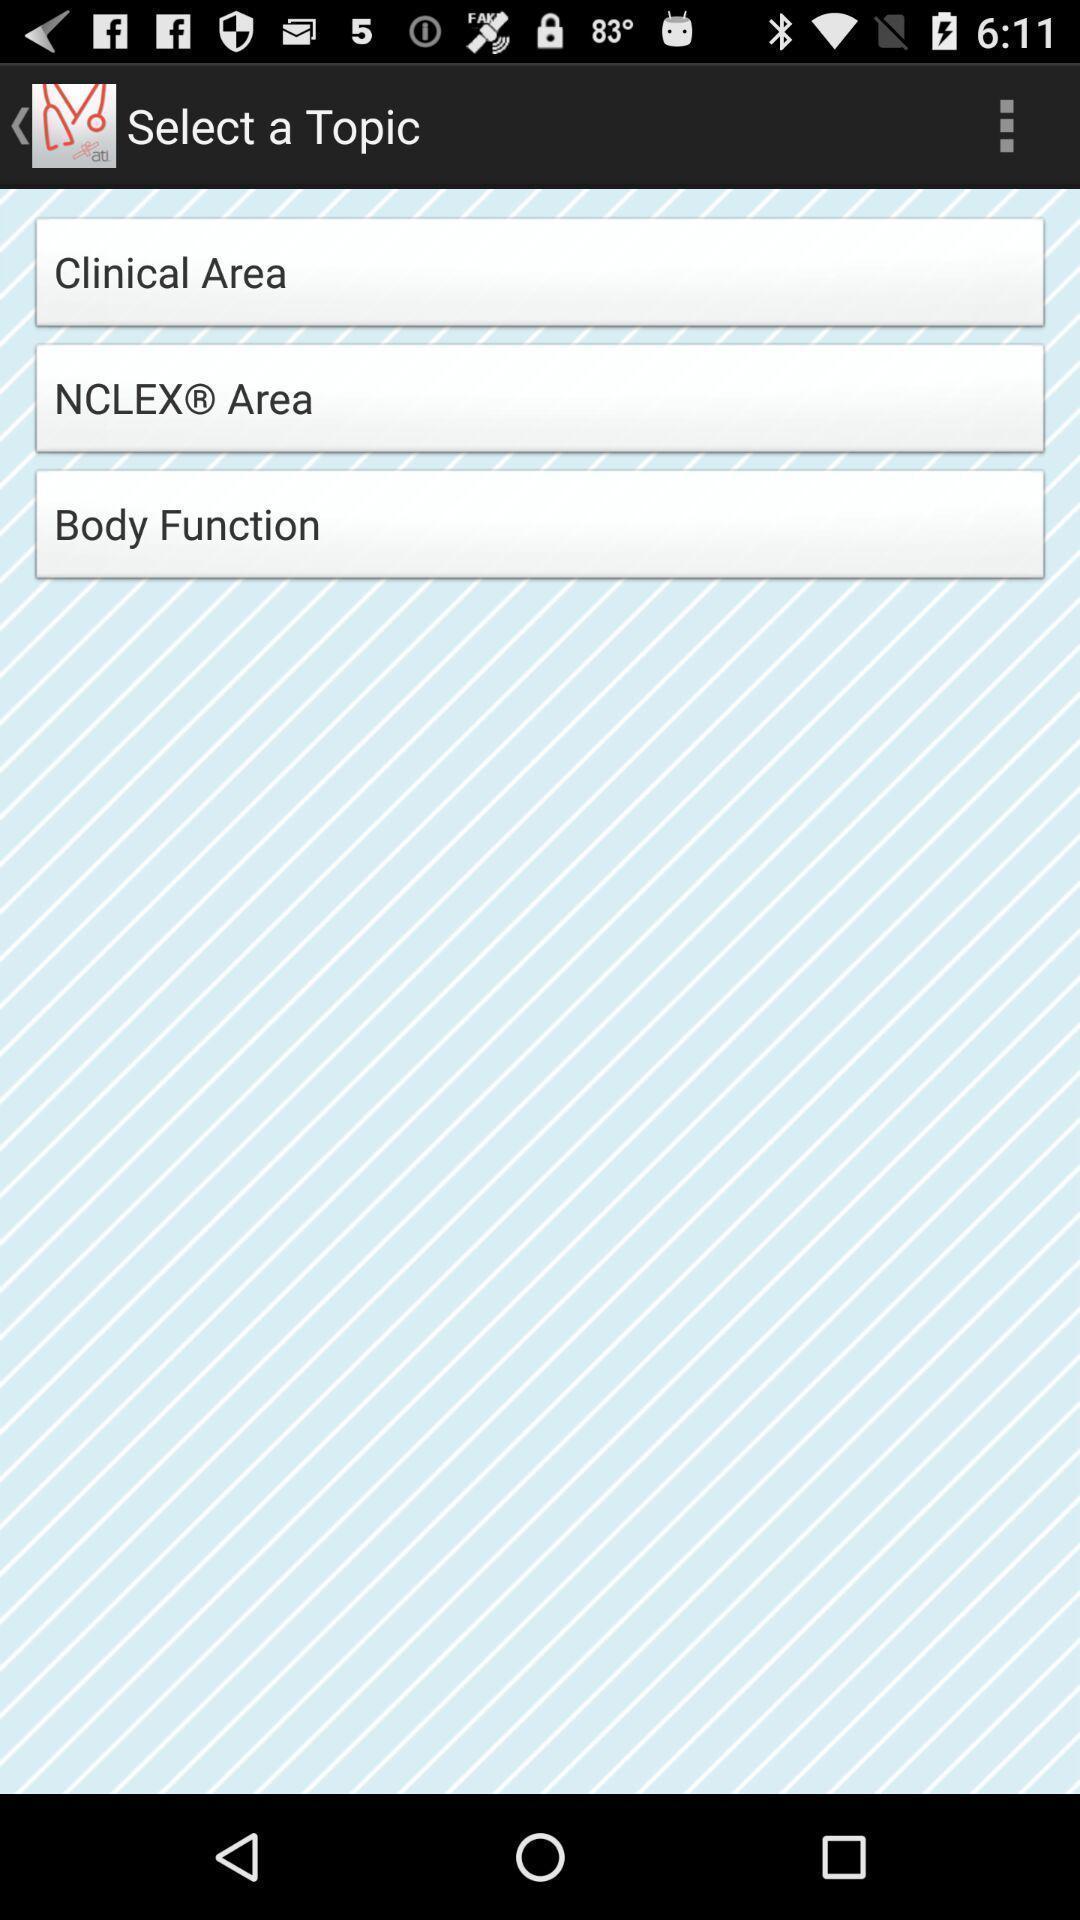Provide a detailed account of this screenshot. Page showing list of various option of a health app. 